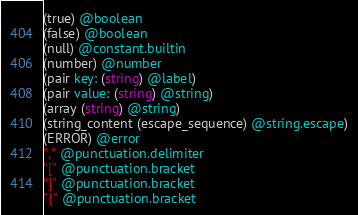Convert code to text. <code><loc_0><loc_0><loc_500><loc_500><_Scheme_>(true) @boolean
(false) @boolean
(null) @constant.builtin
(number) @number
(pair key: (string) @label)
(pair value: (string) @string)
(array (string) @string)
(string_content (escape_sequence) @string.escape)
(ERROR) @error
"," @punctuation.delimiter
"[" @punctuation.bracket
"]" @punctuation.bracket
"{" @punctuation.bracket</code> 